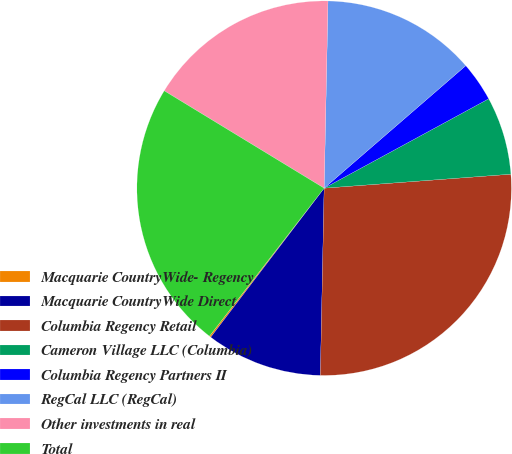Convert chart to OTSL. <chart><loc_0><loc_0><loc_500><loc_500><pie_chart><fcel>Macquarie CountryWide- Regency<fcel>Macquarie CountryWide Direct<fcel>Columbia Regency Retail<fcel>Cameron Village LLC (Columbia)<fcel>Columbia Regency Partners II<fcel>RegCal LLC (RegCal)<fcel>Other investments in real<fcel>Total<nl><fcel>0.14%<fcel>10.03%<fcel>26.51%<fcel>6.73%<fcel>3.43%<fcel>13.32%<fcel>16.62%<fcel>23.21%<nl></chart> 